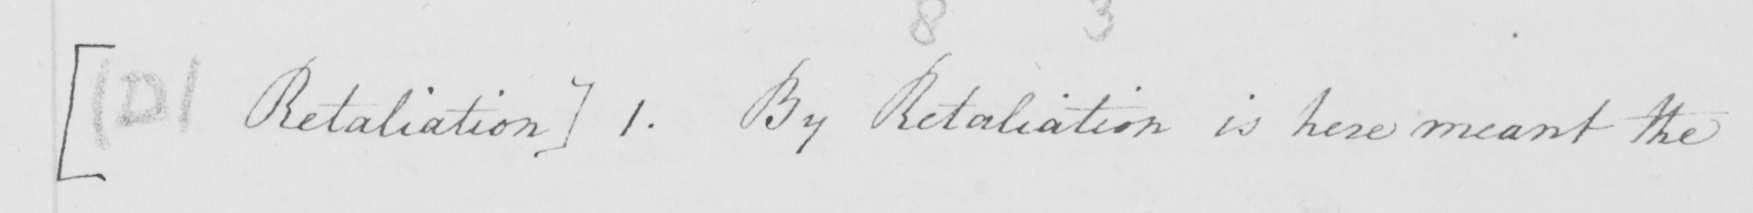Please provide the text content of this handwritten line. [  ( D )  Retaliation ]  1 . By Retaliation is here meant the 